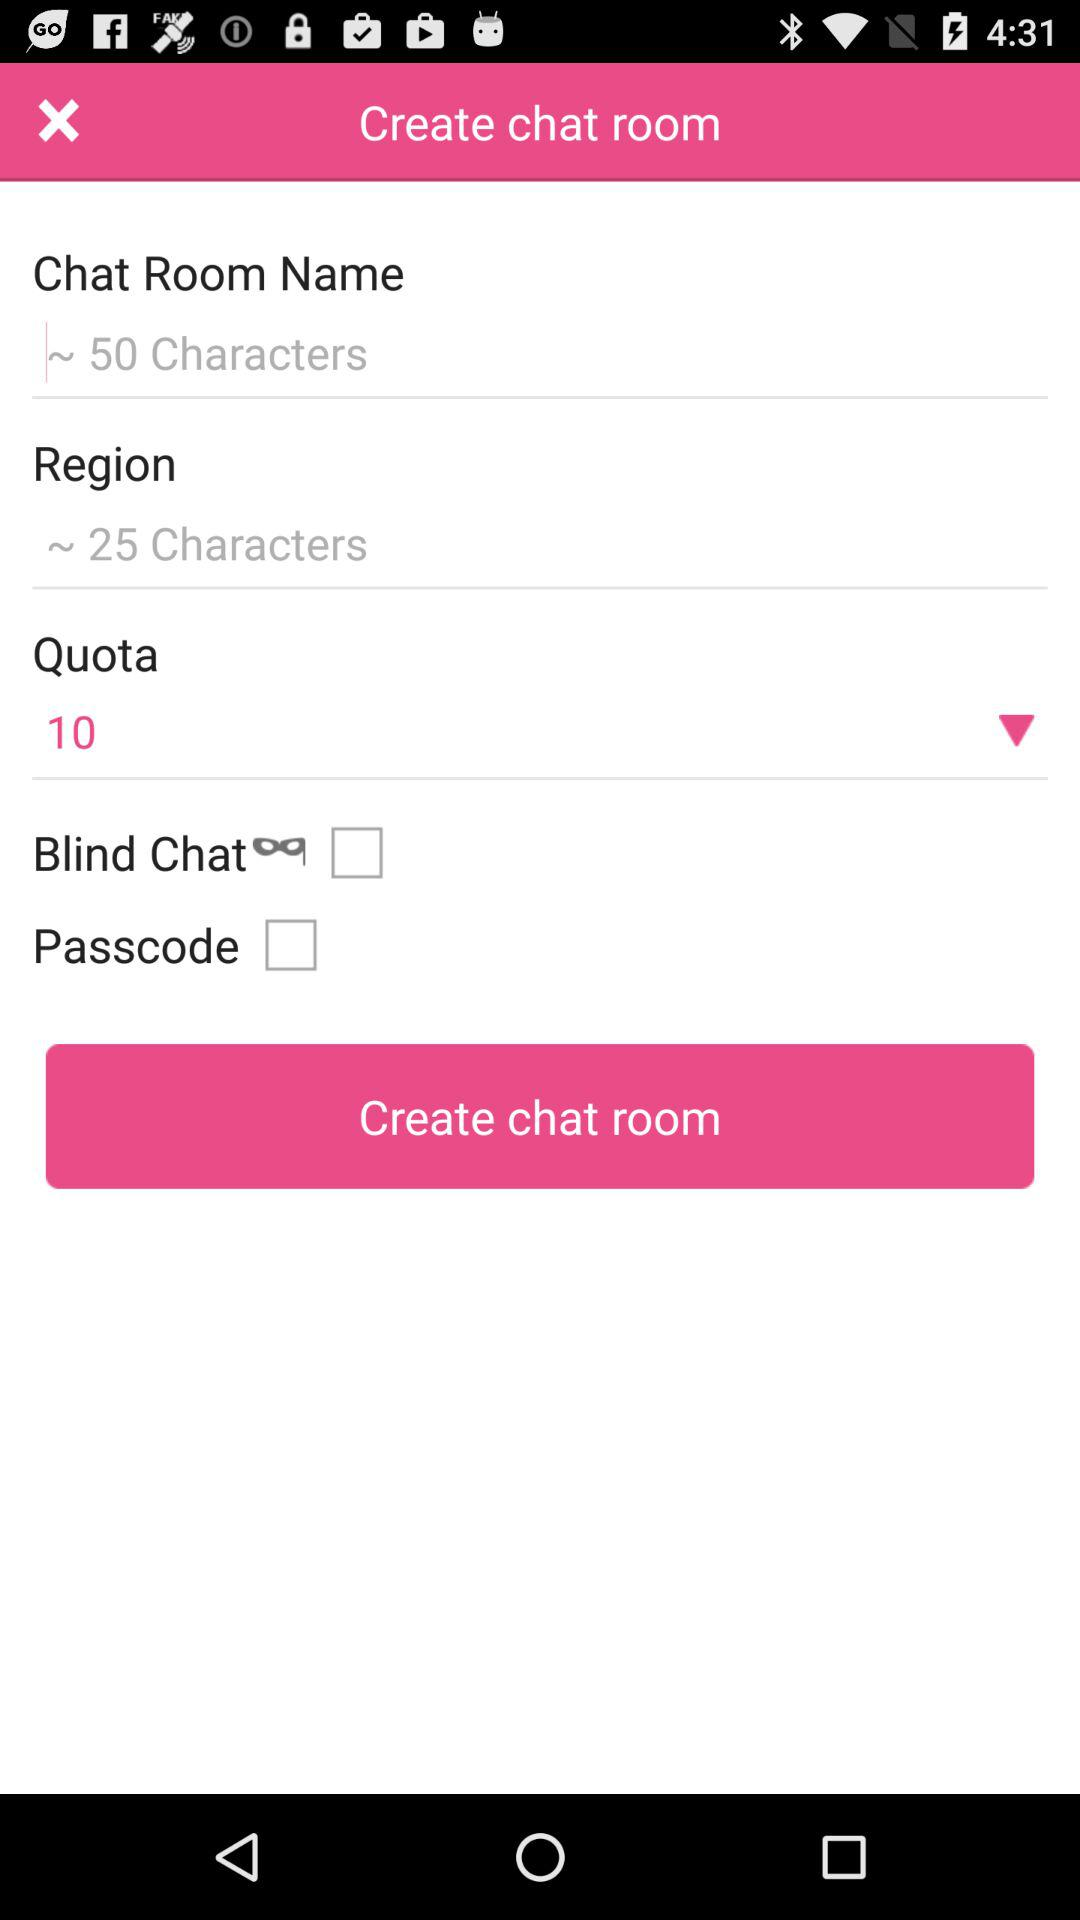What is the number of characters in the "Region"? The number of characters is 25. 